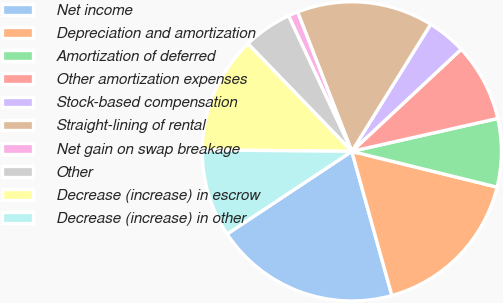Convert chart to OTSL. <chart><loc_0><loc_0><loc_500><loc_500><pie_chart><fcel>Net income<fcel>Depreciation and amortization<fcel>Amortization of deferred<fcel>Other amortization expenses<fcel>Stock-based compensation<fcel>Straight-lining of rental<fcel>Net gain on swap breakage<fcel>Other<fcel>Decrease (increase) in escrow<fcel>Decrease (increase) in other<nl><fcel>20.0%<fcel>16.84%<fcel>7.37%<fcel>8.42%<fcel>4.21%<fcel>14.74%<fcel>1.05%<fcel>5.26%<fcel>12.63%<fcel>9.47%<nl></chart> 